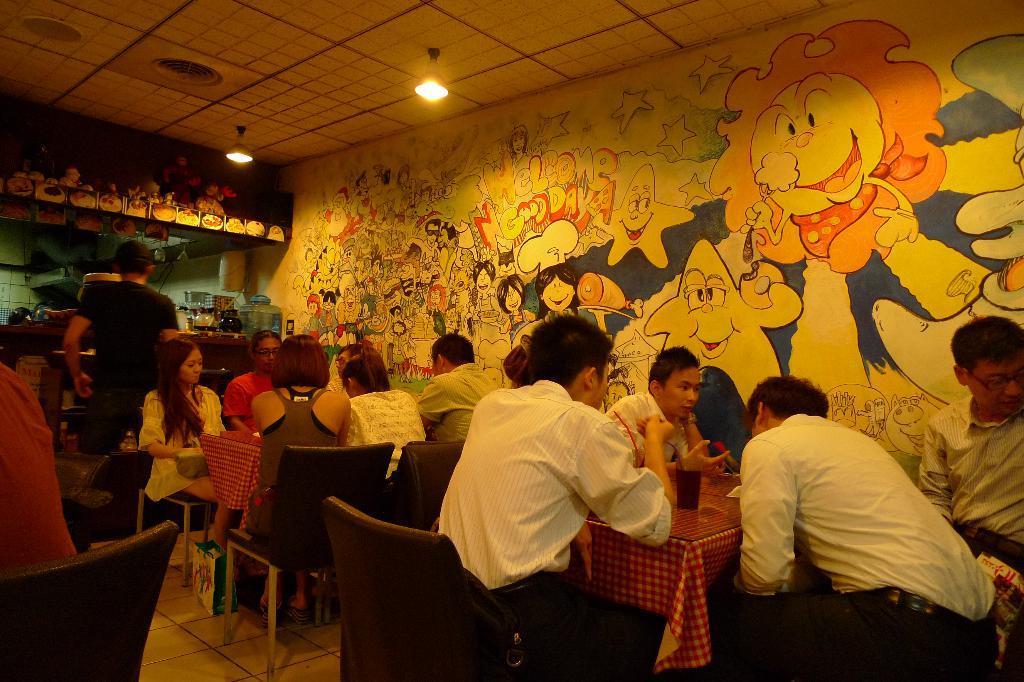In one or two sentences, can you explain what this image depicts? In the image we can see there are lot of people who are sitting on chair and there is a person standing near the kitchen. 